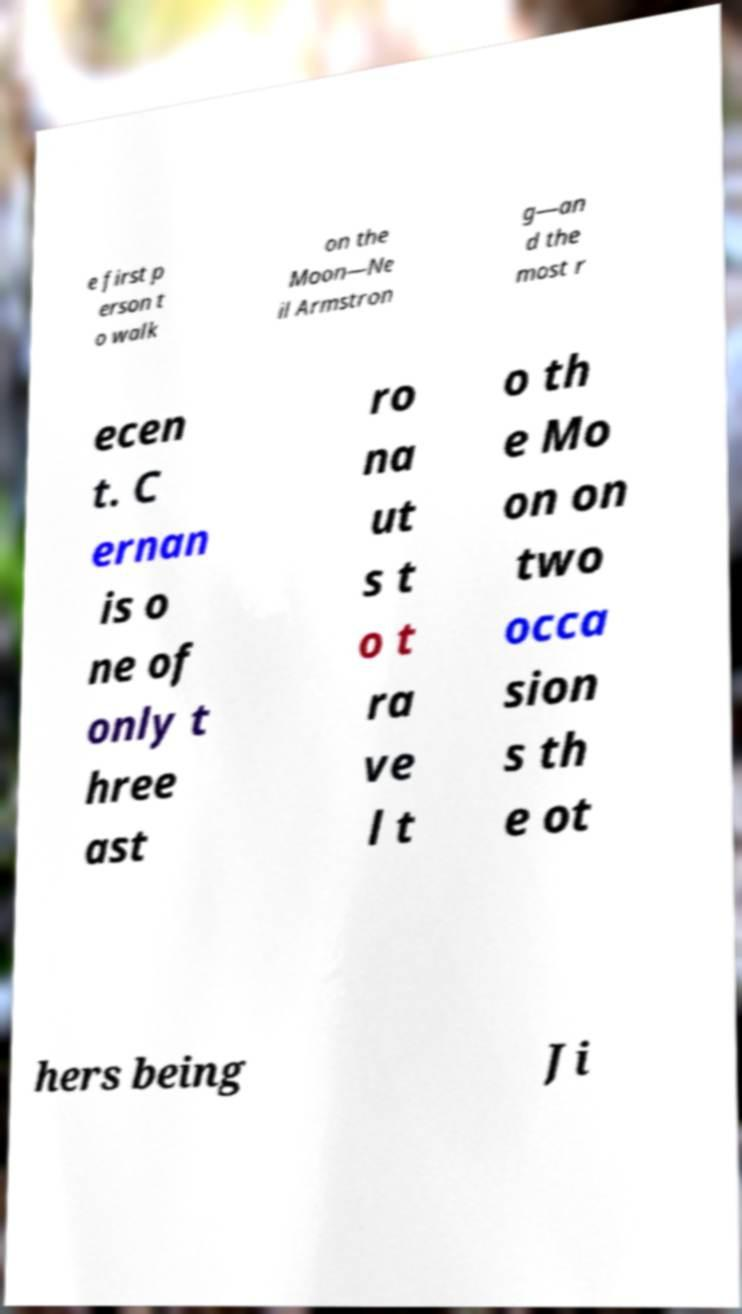Could you assist in decoding the text presented in this image and type it out clearly? e first p erson t o walk on the Moon—Ne il Armstron g—an d the most r ecen t. C ernan is o ne of only t hree ast ro na ut s t o t ra ve l t o th e Mo on on two occa sion s th e ot hers being Ji 